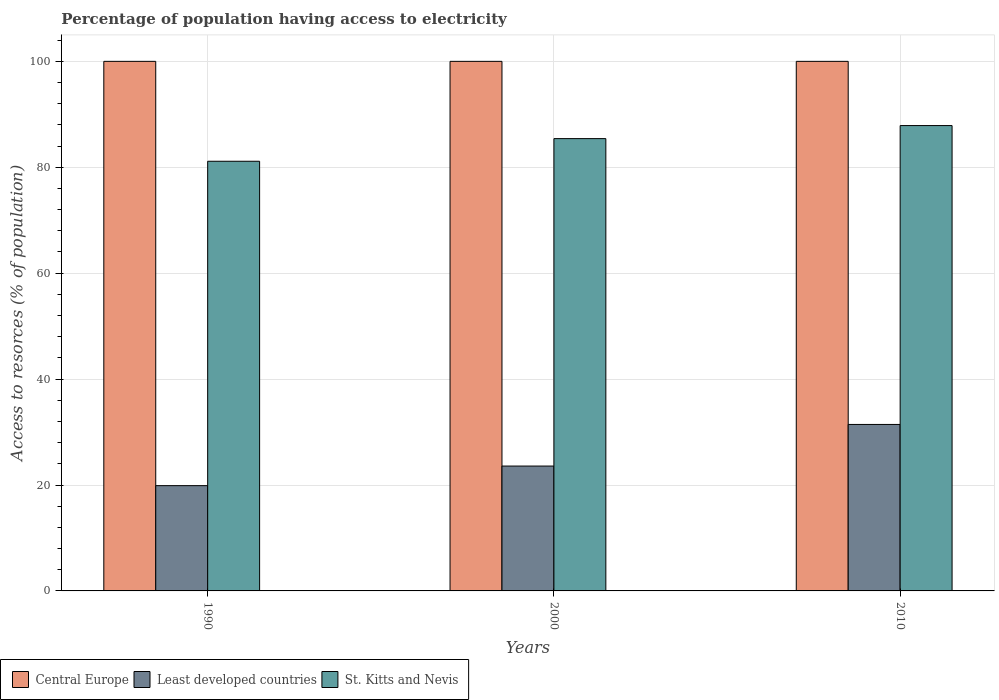Are the number of bars per tick equal to the number of legend labels?
Keep it short and to the point. Yes. How many bars are there on the 1st tick from the left?
Make the answer very short. 3. What is the label of the 2nd group of bars from the left?
Make the answer very short. 2000. What is the percentage of population having access to electricity in Least developed countries in 1990?
Make the answer very short. 19.88. Across all years, what is the maximum percentage of population having access to electricity in Least developed countries?
Your answer should be compact. 31.44. Across all years, what is the minimum percentage of population having access to electricity in Central Europe?
Your answer should be compact. 100. In which year was the percentage of population having access to electricity in Least developed countries maximum?
Your answer should be compact. 2010. What is the total percentage of population having access to electricity in Central Europe in the graph?
Your answer should be very brief. 300. What is the difference between the percentage of population having access to electricity in St. Kitts and Nevis in 1990 and that in 2000?
Make the answer very short. -4.28. What is the difference between the percentage of population having access to electricity in Central Europe in 2000 and the percentage of population having access to electricity in St. Kitts and Nevis in 1990?
Make the answer very short. 18.86. What is the average percentage of population having access to electricity in St. Kitts and Nevis per year?
Ensure brevity in your answer.  84.81. In the year 2000, what is the difference between the percentage of population having access to electricity in Least developed countries and percentage of population having access to electricity in St. Kitts and Nevis?
Your response must be concise. -61.83. In how many years, is the percentage of population having access to electricity in St. Kitts and Nevis greater than 60 %?
Give a very brief answer. 3. What is the ratio of the percentage of population having access to electricity in St. Kitts and Nevis in 1990 to that in 2000?
Give a very brief answer. 0.95. Is the difference between the percentage of population having access to electricity in Least developed countries in 1990 and 2000 greater than the difference between the percentage of population having access to electricity in St. Kitts and Nevis in 1990 and 2000?
Ensure brevity in your answer.  Yes. What is the difference between the highest and the second highest percentage of population having access to electricity in St. Kitts and Nevis?
Offer a very short reply. 2.46. What is the difference between the highest and the lowest percentage of population having access to electricity in St. Kitts and Nevis?
Provide a succinct answer. 6.74. Is the sum of the percentage of population having access to electricity in St. Kitts and Nevis in 1990 and 2010 greater than the maximum percentage of population having access to electricity in Central Europe across all years?
Give a very brief answer. Yes. What does the 3rd bar from the left in 2000 represents?
Provide a succinct answer. St. Kitts and Nevis. What does the 2nd bar from the right in 1990 represents?
Offer a terse response. Least developed countries. How many bars are there?
Make the answer very short. 9. How many years are there in the graph?
Offer a terse response. 3. Are the values on the major ticks of Y-axis written in scientific E-notation?
Provide a succinct answer. No. Where does the legend appear in the graph?
Your answer should be compact. Bottom left. How are the legend labels stacked?
Your response must be concise. Horizontal. What is the title of the graph?
Provide a succinct answer. Percentage of population having access to electricity. Does "Bahrain" appear as one of the legend labels in the graph?
Make the answer very short. No. What is the label or title of the X-axis?
Offer a very short reply. Years. What is the label or title of the Y-axis?
Your answer should be compact. Access to resorces (% of population). What is the Access to resorces (% of population) of Least developed countries in 1990?
Your answer should be compact. 19.88. What is the Access to resorces (% of population) in St. Kitts and Nevis in 1990?
Keep it short and to the point. 81.14. What is the Access to resorces (% of population) of Central Europe in 2000?
Make the answer very short. 100. What is the Access to resorces (% of population) in Least developed countries in 2000?
Make the answer very short. 23.58. What is the Access to resorces (% of population) of St. Kitts and Nevis in 2000?
Give a very brief answer. 85.41. What is the Access to resorces (% of population) of Central Europe in 2010?
Your answer should be very brief. 100. What is the Access to resorces (% of population) of Least developed countries in 2010?
Offer a terse response. 31.44. What is the Access to resorces (% of population) of St. Kitts and Nevis in 2010?
Give a very brief answer. 87.87. Across all years, what is the maximum Access to resorces (% of population) in Central Europe?
Make the answer very short. 100. Across all years, what is the maximum Access to resorces (% of population) of Least developed countries?
Provide a succinct answer. 31.44. Across all years, what is the maximum Access to resorces (% of population) in St. Kitts and Nevis?
Make the answer very short. 87.87. Across all years, what is the minimum Access to resorces (% of population) of Least developed countries?
Make the answer very short. 19.88. Across all years, what is the minimum Access to resorces (% of population) in St. Kitts and Nevis?
Your answer should be very brief. 81.14. What is the total Access to resorces (% of population) in Central Europe in the graph?
Offer a very short reply. 300. What is the total Access to resorces (% of population) in Least developed countries in the graph?
Your answer should be very brief. 74.89. What is the total Access to resorces (% of population) of St. Kitts and Nevis in the graph?
Your answer should be compact. 254.42. What is the difference between the Access to resorces (% of population) in Least developed countries in 1990 and that in 2000?
Provide a short and direct response. -3.7. What is the difference between the Access to resorces (% of population) in St. Kitts and Nevis in 1990 and that in 2000?
Your answer should be very brief. -4.28. What is the difference between the Access to resorces (% of population) of Central Europe in 1990 and that in 2010?
Keep it short and to the point. 0. What is the difference between the Access to resorces (% of population) of Least developed countries in 1990 and that in 2010?
Offer a terse response. -11.56. What is the difference between the Access to resorces (% of population) of St. Kitts and Nevis in 1990 and that in 2010?
Your response must be concise. -6.74. What is the difference between the Access to resorces (% of population) in Least developed countries in 2000 and that in 2010?
Give a very brief answer. -7.86. What is the difference between the Access to resorces (% of population) of St. Kitts and Nevis in 2000 and that in 2010?
Your answer should be compact. -2.46. What is the difference between the Access to resorces (% of population) in Central Europe in 1990 and the Access to resorces (% of population) in Least developed countries in 2000?
Provide a short and direct response. 76.42. What is the difference between the Access to resorces (% of population) of Central Europe in 1990 and the Access to resorces (% of population) of St. Kitts and Nevis in 2000?
Keep it short and to the point. 14.59. What is the difference between the Access to resorces (% of population) in Least developed countries in 1990 and the Access to resorces (% of population) in St. Kitts and Nevis in 2000?
Ensure brevity in your answer.  -65.53. What is the difference between the Access to resorces (% of population) of Central Europe in 1990 and the Access to resorces (% of population) of Least developed countries in 2010?
Ensure brevity in your answer.  68.56. What is the difference between the Access to resorces (% of population) of Central Europe in 1990 and the Access to resorces (% of population) of St. Kitts and Nevis in 2010?
Provide a succinct answer. 12.13. What is the difference between the Access to resorces (% of population) of Least developed countries in 1990 and the Access to resorces (% of population) of St. Kitts and Nevis in 2010?
Your answer should be very brief. -68. What is the difference between the Access to resorces (% of population) in Central Europe in 2000 and the Access to resorces (% of population) in Least developed countries in 2010?
Provide a short and direct response. 68.56. What is the difference between the Access to resorces (% of population) in Central Europe in 2000 and the Access to resorces (% of population) in St. Kitts and Nevis in 2010?
Your answer should be compact. 12.13. What is the difference between the Access to resorces (% of population) of Least developed countries in 2000 and the Access to resorces (% of population) of St. Kitts and Nevis in 2010?
Provide a succinct answer. -64.29. What is the average Access to resorces (% of population) of Least developed countries per year?
Your answer should be very brief. 24.96. What is the average Access to resorces (% of population) in St. Kitts and Nevis per year?
Give a very brief answer. 84.81. In the year 1990, what is the difference between the Access to resorces (% of population) in Central Europe and Access to resorces (% of population) in Least developed countries?
Your response must be concise. 80.12. In the year 1990, what is the difference between the Access to resorces (% of population) in Central Europe and Access to resorces (% of population) in St. Kitts and Nevis?
Offer a terse response. 18.86. In the year 1990, what is the difference between the Access to resorces (% of population) of Least developed countries and Access to resorces (% of population) of St. Kitts and Nevis?
Offer a terse response. -61.26. In the year 2000, what is the difference between the Access to resorces (% of population) in Central Europe and Access to resorces (% of population) in Least developed countries?
Offer a very short reply. 76.42. In the year 2000, what is the difference between the Access to resorces (% of population) in Central Europe and Access to resorces (% of population) in St. Kitts and Nevis?
Make the answer very short. 14.59. In the year 2000, what is the difference between the Access to resorces (% of population) in Least developed countries and Access to resorces (% of population) in St. Kitts and Nevis?
Your response must be concise. -61.83. In the year 2010, what is the difference between the Access to resorces (% of population) of Central Europe and Access to resorces (% of population) of Least developed countries?
Offer a terse response. 68.56. In the year 2010, what is the difference between the Access to resorces (% of population) in Central Europe and Access to resorces (% of population) in St. Kitts and Nevis?
Provide a short and direct response. 12.13. In the year 2010, what is the difference between the Access to resorces (% of population) of Least developed countries and Access to resorces (% of population) of St. Kitts and Nevis?
Your response must be concise. -56.44. What is the ratio of the Access to resorces (% of population) in Central Europe in 1990 to that in 2000?
Keep it short and to the point. 1. What is the ratio of the Access to resorces (% of population) of Least developed countries in 1990 to that in 2000?
Offer a terse response. 0.84. What is the ratio of the Access to resorces (% of population) of St. Kitts and Nevis in 1990 to that in 2000?
Ensure brevity in your answer.  0.95. What is the ratio of the Access to resorces (% of population) in Least developed countries in 1990 to that in 2010?
Provide a succinct answer. 0.63. What is the ratio of the Access to resorces (% of population) in St. Kitts and Nevis in 1990 to that in 2010?
Provide a short and direct response. 0.92. What is the ratio of the Access to resorces (% of population) of Least developed countries in 2000 to that in 2010?
Ensure brevity in your answer.  0.75. What is the ratio of the Access to resorces (% of population) of St. Kitts and Nevis in 2000 to that in 2010?
Your answer should be very brief. 0.97. What is the difference between the highest and the second highest Access to resorces (% of population) in Least developed countries?
Provide a succinct answer. 7.86. What is the difference between the highest and the second highest Access to resorces (% of population) in St. Kitts and Nevis?
Offer a terse response. 2.46. What is the difference between the highest and the lowest Access to resorces (% of population) in Central Europe?
Keep it short and to the point. 0. What is the difference between the highest and the lowest Access to resorces (% of population) of Least developed countries?
Offer a terse response. 11.56. What is the difference between the highest and the lowest Access to resorces (% of population) in St. Kitts and Nevis?
Make the answer very short. 6.74. 